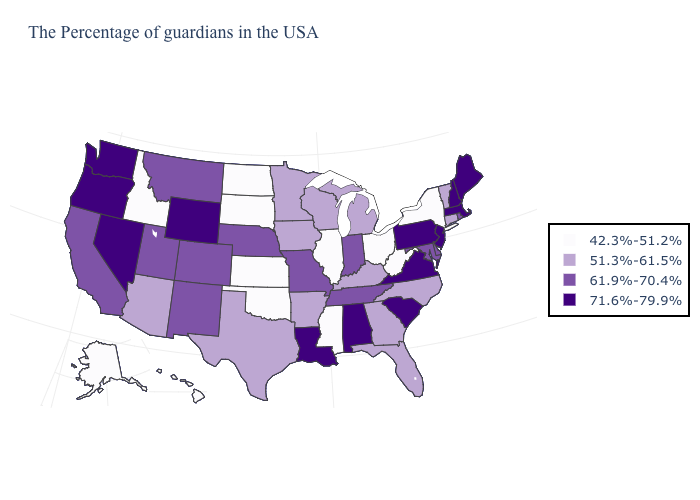Name the states that have a value in the range 42.3%-51.2%?
Quick response, please. New York, West Virginia, Ohio, Illinois, Mississippi, Kansas, Oklahoma, South Dakota, North Dakota, Idaho, Alaska, Hawaii. Name the states that have a value in the range 51.3%-61.5%?
Short answer required. Vermont, Connecticut, North Carolina, Florida, Georgia, Michigan, Kentucky, Wisconsin, Arkansas, Minnesota, Iowa, Texas, Arizona. Name the states that have a value in the range 61.9%-70.4%?
Quick response, please. Rhode Island, Delaware, Maryland, Indiana, Tennessee, Missouri, Nebraska, Colorado, New Mexico, Utah, Montana, California. What is the highest value in the West ?
Answer briefly. 71.6%-79.9%. What is the highest value in states that border New Hampshire?
Concise answer only. 71.6%-79.9%. Name the states that have a value in the range 71.6%-79.9%?
Quick response, please. Maine, Massachusetts, New Hampshire, New Jersey, Pennsylvania, Virginia, South Carolina, Alabama, Louisiana, Wyoming, Nevada, Washington, Oregon. What is the highest value in the USA?
Keep it brief. 71.6%-79.9%. Which states hav the highest value in the South?
Be succinct. Virginia, South Carolina, Alabama, Louisiana. Does Michigan have the same value as Arizona?
Answer briefly. Yes. What is the highest value in states that border Illinois?
Concise answer only. 61.9%-70.4%. Does the map have missing data?
Give a very brief answer. No. What is the lowest value in the USA?
Answer briefly. 42.3%-51.2%. Does Ohio have the lowest value in the MidWest?
Write a very short answer. Yes. What is the value of Georgia?
Answer briefly. 51.3%-61.5%. Which states hav the highest value in the South?
Quick response, please. Virginia, South Carolina, Alabama, Louisiana. 